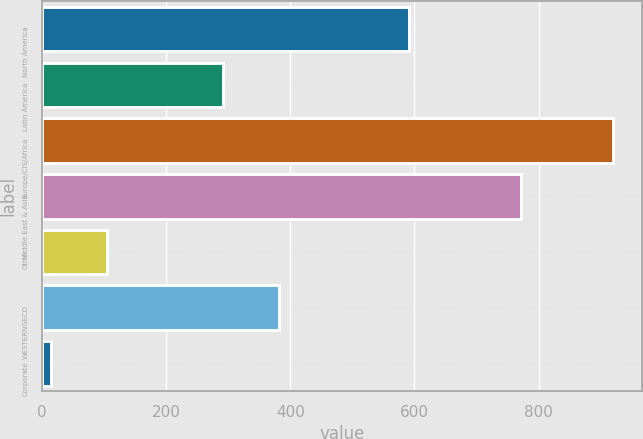Convert chart. <chart><loc_0><loc_0><loc_500><loc_500><bar_chart><fcel>North America<fcel>Latin America<fcel>Europe/CIS/Africa<fcel>Middle East & Asia<fcel>Other<fcel>WESTERNGECO<fcel>Corporate<nl><fcel>591<fcel>292<fcel>920<fcel>772<fcel>105.5<fcel>382.5<fcel>15<nl></chart> 